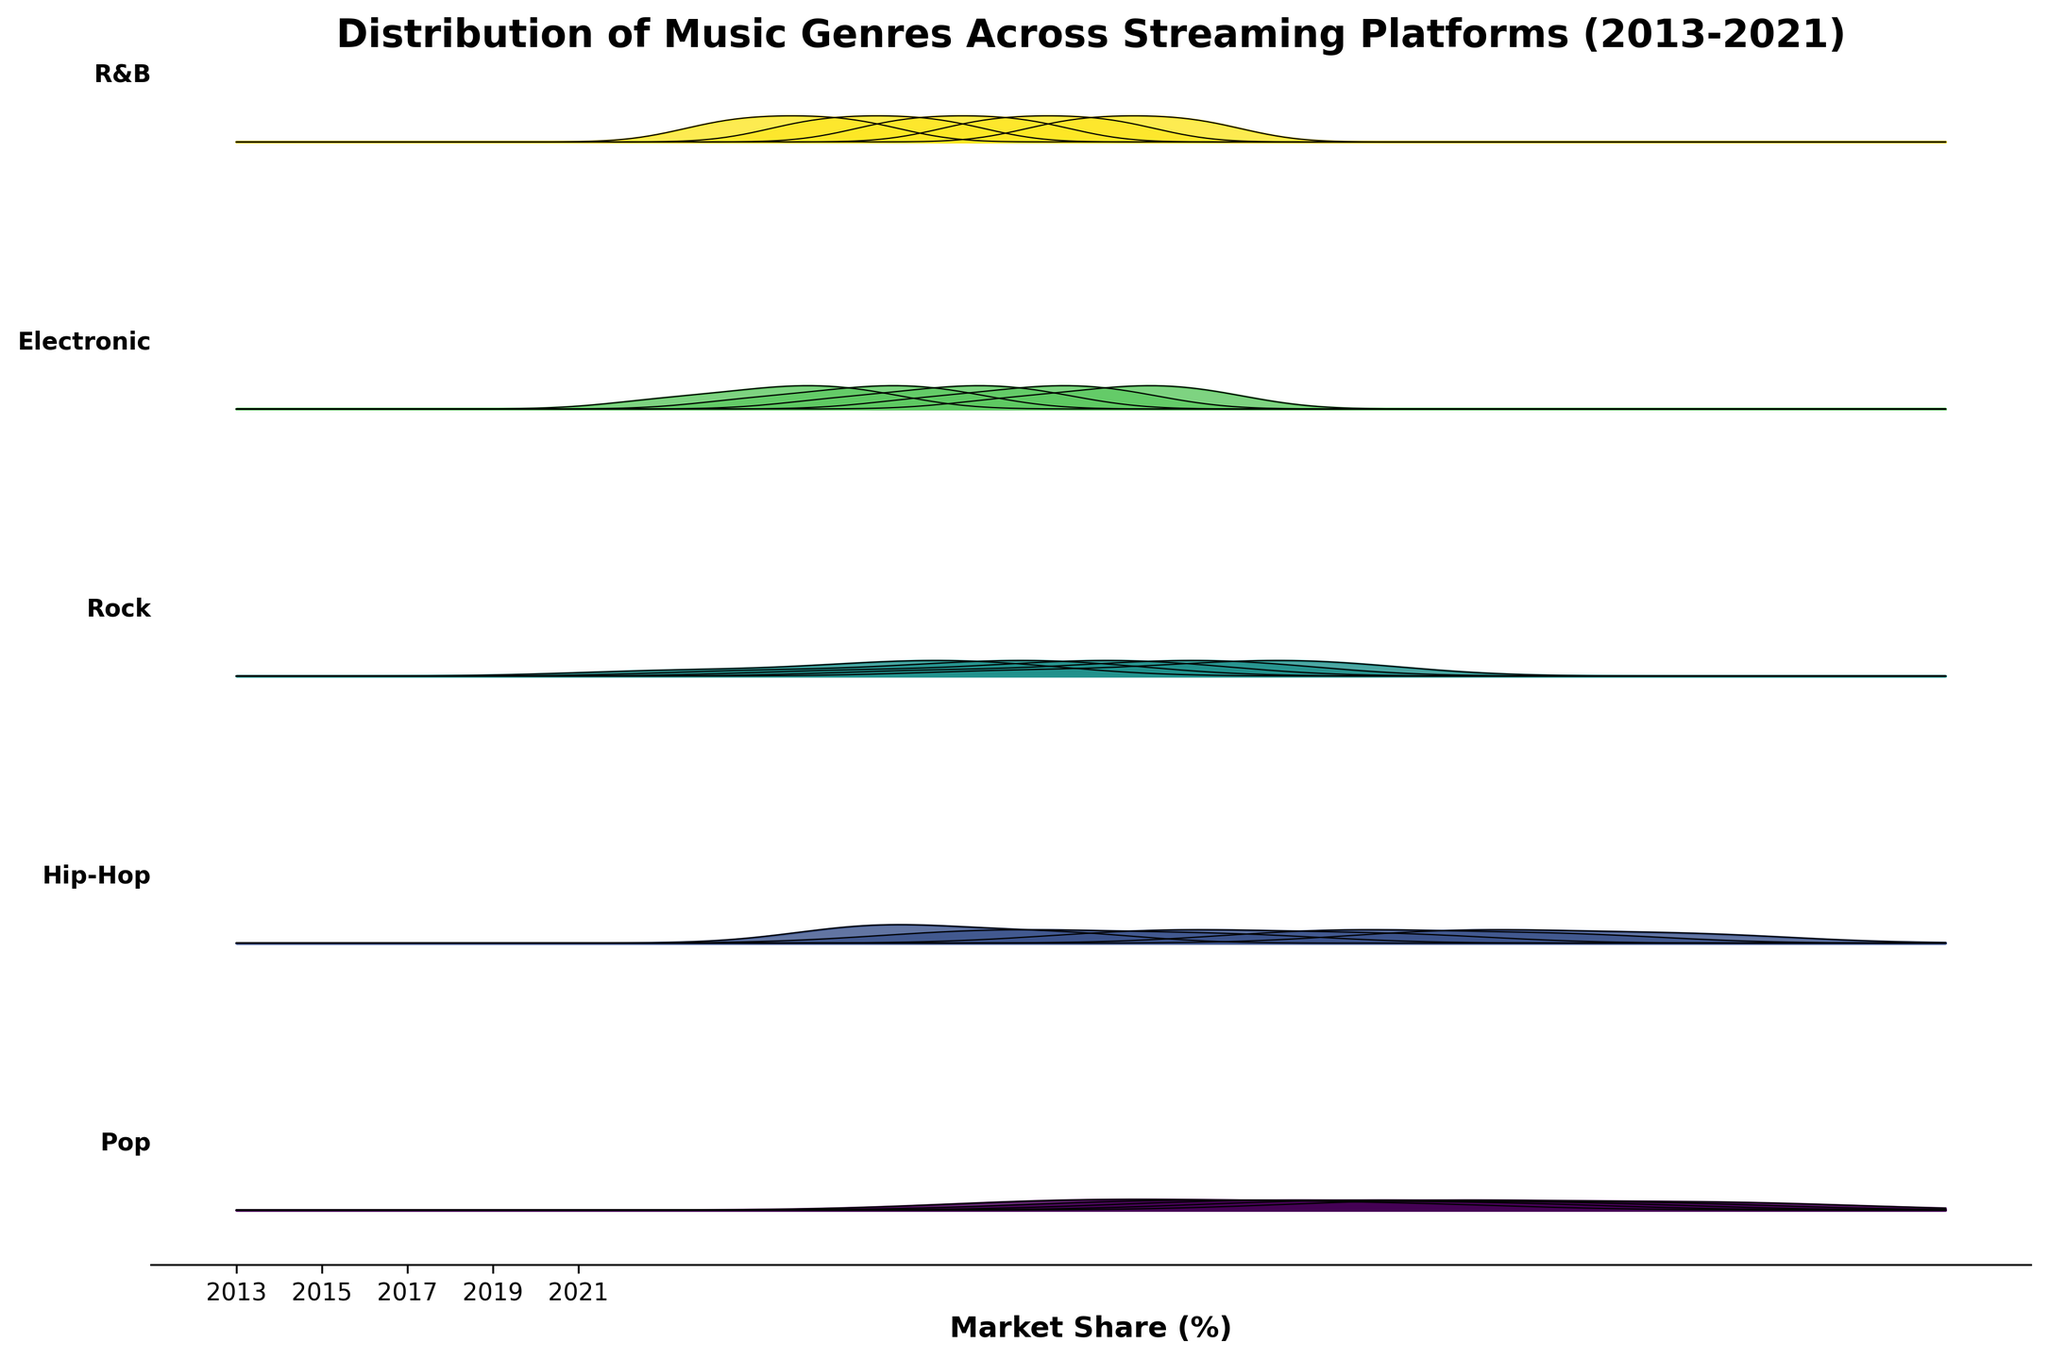What is the title of the figure? The figure's title is typically located at the top and will give an overview or context of the plot.
Answer: Distribution of Music Genres Across Streaming Platforms (2013-2021) Which genre has the highest peak in its distribution in 2017? To find the genre with the highest peak, locate the year 2017 and compare the peaks of each genre’s distribution curve for that year.
Answer: Pop How does the market share of Pop in Spotify change from 2013 to 2021? Observe the distribution curves for the Pop genre from 2013 to 2021 and note the changes in the peak positions for Spotify.
Answer: It increases Which genre shows the greatest relative increase in market share on YouTube Music from 2013 to 2021? Compare the distribution peaks for each genre on YouTube Music from 2013 and 2021 and identify which genre has the most significant rise.
Answer: Hip-Hop Between 2013 and 2021, which music genre's distribution appears to become more concentrated on Spotify? Analyze the distribution width of each genre on Spotify from 2013 to 2021 to determine which one becomes less spread out (more concentrated) over time.
Answer: Pop What platform has the least variety in market share for genres in 2021? Look at the distribution curves for 2021 across all platforms and determine which platform has the most uniform distribution (least variation in heights).
Answer: Tidal Which genre’s popularity on Amazon Music has decreased the most from 2013 to 2021? Compare the distribution curves for each genre on Amazon Music from 2013 and 2021 and identify which has the largest decline in its peak height.
Answer: Rock How does the distribution width of Electronic music on Apple Music compare between 2013 and 2021? Compare the spread of the distribution curve for Electronic music on Apple Music in 2013 and 2021 to determine changes in width.
Answer: It becomes wider In 2019, which genre had a more even market share distribution across all platforms? Find the genre whose distribution curve in 2019 shows a relatively uniform height across all platforms rather than peaking on a specific one.
Answer: Electronic 